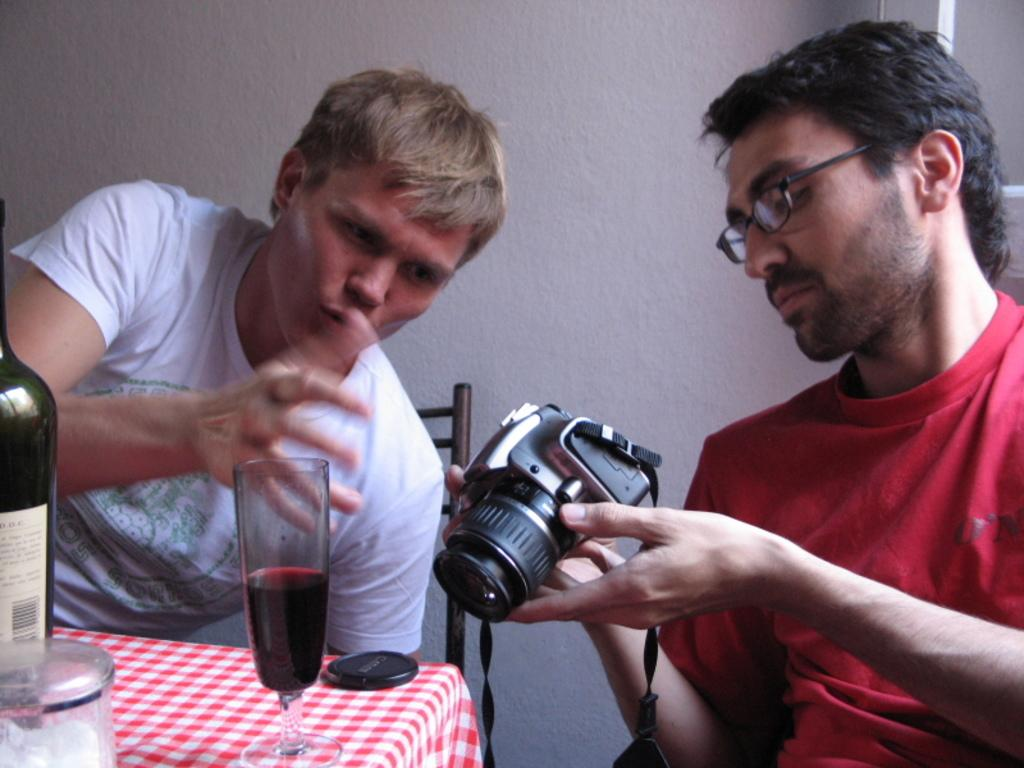How many people are in the image? There are two persons in the image. What are the positions of the persons in the image? Both persons are sitting in chairs. What is one person doing in the image? One person is holding a camera. Where is the other person sitting in relation to the table? The other person is sitting near a table. What objects can be seen on the table? There is a bottle and a glass on the table. What type of doll is sitting on the chair next to the person holding the camera? There is no doll present in the image; only two persons, chairs, a camera, a table, a bottle, and a glass are visible. 